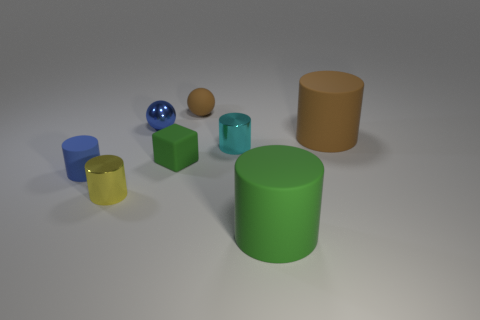Subtract all green cylinders. How many cylinders are left? 4 Subtract all tiny cyan cylinders. How many cylinders are left? 4 Add 2 green rubber things. How many objects exist? 10 Subtract all red cylinders. Subtract all gray balls. How many cylinders are left? 5 Subtract all balls. How many objects are left? 6 Add 7 tiny cylinders. How many tiny cylinders are left? 10 Add 8 tiny gray shiny blocks. How many tiny gray shiny blocks exist? 8 Subtract 0 yellow blocks. How many objects are left? 8 Subtract all tiny green rubber objects. Subtract all small brown matte things. How many objects are left? 6 